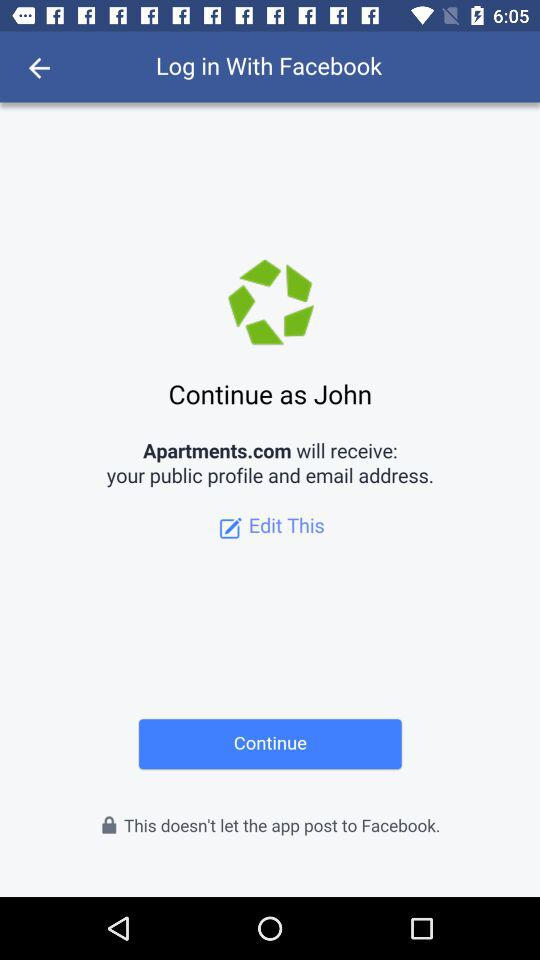What is the user name to continue the profile? The user name to continue the profile is John. 